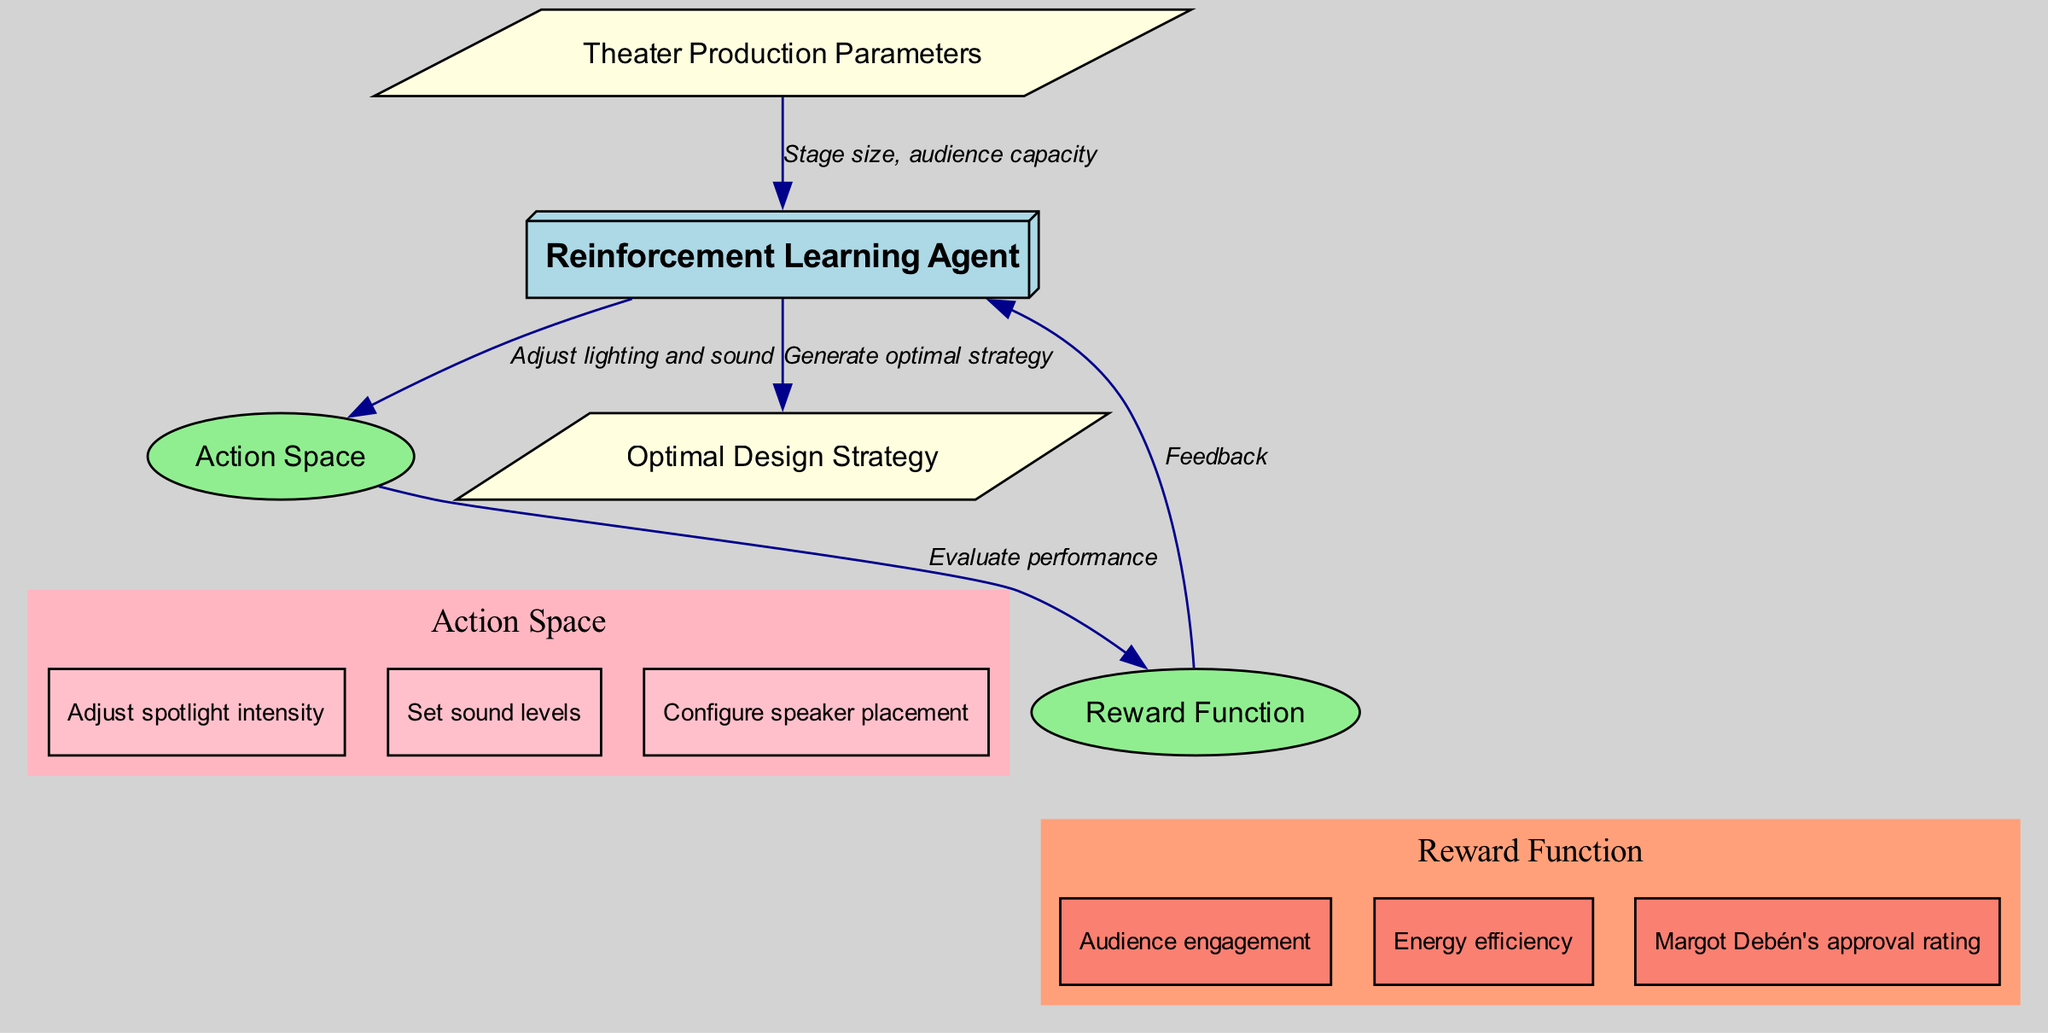What are the parameters provided to the reinforcement learning agent? The parameters provided involve stage size and audience capacity, which are transferred from the input to the reinforcement learning agent. This is described by the edge connecting the "Theater Production Parameters" node to the "Reinforcement Learning Agent" node.
Answer: Stage size, audience capacity Which strategy is generated by the reinforcement learning agent? The output from the reinforcement learning agent, indicated in the diagram, specifies the optimal design strategy, which is the final result produced after processing the input and rewards.
Answer: Optimal Design Strategy How many nodes are present in the diagram? By counting the nodes listed in the diagram, we find five: Theater Production Parameters, Reinforcement Learning Agent, Action Space, Reward Function, and Optimal Design Strategy.
Answer: Five What is the first action in the action space? The first action listed in the action space, represented visually as a sub-node of the action space cluster, is related to adjusting spotlight intensity. This can be deduced from the list shown within the action space.
Answer: Adjust spotlight intensity What type of feedback does the reinforcement learning agent receive? The feedback to the reinforcement learning agent comes from the reward function, which evaluates various factors including audience engagement, energy efficiency, and Margot Debén's approval rating. This relationship is shown by the edges connecting the reward function back to the agent.
Answer: Feedback Which reward is listed that is related to audience interaction? One reward associated with audience interaction is audience engagement, which is explicitly listed as a part of the reward function sub-node. This can be observed clearly in the diagram under the rewards section.
Answer: Audience engagement How does the reinforcement learning agent evaluate its actions? The reinforcement learning agent evaluates its actions by assessing the performance based on the reward function, which takes input from the action space's adjustments. This sequential flow is denoted by the edges connecting the action space to the reward.
Answer: Evaluate performance What is the shape used for the reinforcement learning agent node? The node representing the reinforcement learning agent has a box 3D shape, which is a specific visual designation defined for that node in the diagram to highlight its importance in the process.
Answer: Box 3D 